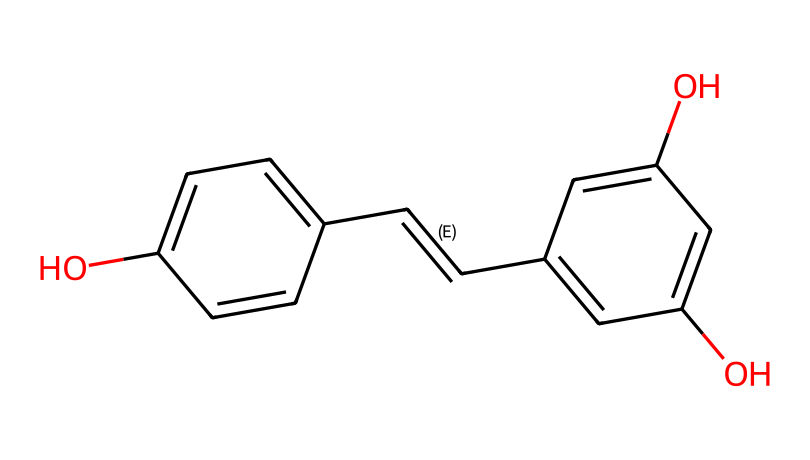What is the chemical name of this structure? The structure represented by the SMILES notation corresponds to resveratrol, which is a well-known antioxidant found in red wine.
Answer: resveratrol How many hydroxyl (OH) groups are present in this molecule? By observing the structure, there are three hydroxyl groups (as indicated by the "O" and the attachment points to the aromatic rings).
Answer: three What is the total number of carbon atoms in this molecule? Counting each carbon in the SMILES representation shows that there are 14 carbon atoms present in the structure of resveratrol.
Answer: fourteen Which part of the structure indicates its antioxidant properties? The presence of the hydroxyl groups (attached to the aromatic rings) suggests the molecule's ability to donate electrons, which is a key feature of antioxidants.
Answer: hydroxyl groups Does this molecule contain any double bonds? The structure contains double bonds between the carbon atoms that link the rings, specifically shown in the /C=C/ part of the SMILES notation.
Answer: yes What type of compound is resveratrol classified as? Based on its chemical structure, which consists of phenolic compounds with multiple hydroxyl groups, resveratrol is classified as a polyphenol.
Answer: polyphenol 